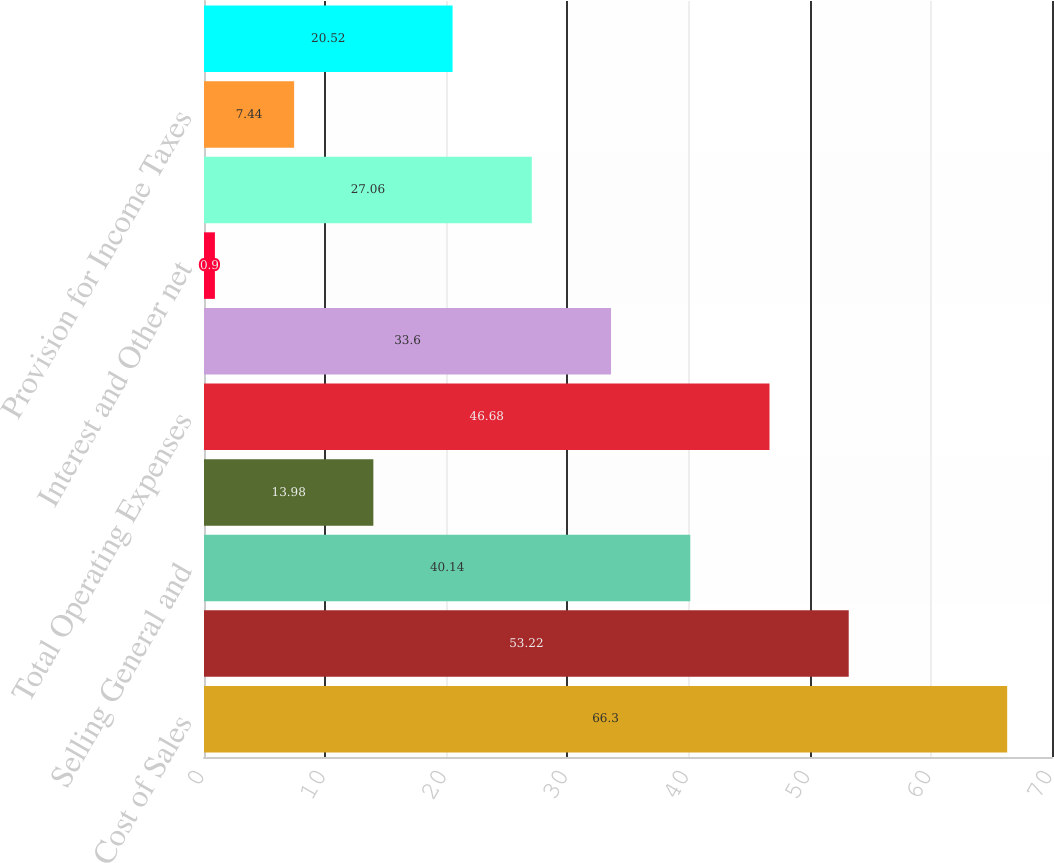Convert chart to OTSL. <chart><loc_0><loc_0><loc_500><loc_500><bar_chart><fcel>Cost of Sales<fcel>Gross Profit<fcel>Selling General and<fcel>Depreciation and Amortization<fcel>Total Operating Expenses<fcel>Operating Income<fcel>Interest and Other net<fcel>Earnings From Continuing<fcel>Provision for Income Taxes<fcel>Earnings from Continuing<nl><fcel>66.3<fcel>53.22<fcel>40.14<fcel>13.98<fcel>46.68<fcel>33.6<fcel>0.9<fcel>27.06<fcel>7.44<fcel>20.52<nl></chart> 